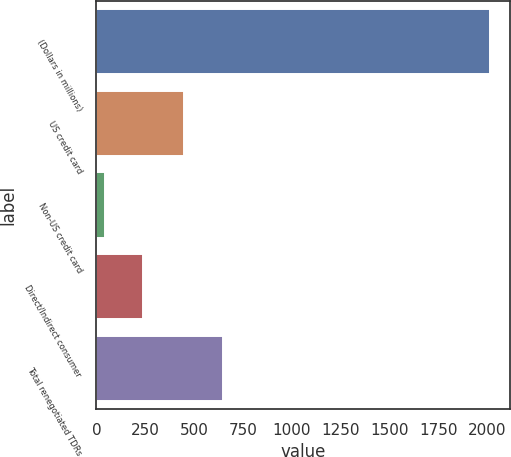Convert chart. <chart><loc_0><loc_0><loc_500><loc_500><bar_chart><fcel>(Dollars in millions)<fcel>US credit card<fcel>Non-US credit card<fcel>Direct/Indirect consumer<fcel>Total renegotiated TDRs<nl><fcel>2014<fcel>450<fcel>41<fcel>238.3<fcel>647.3<nl></chart> 